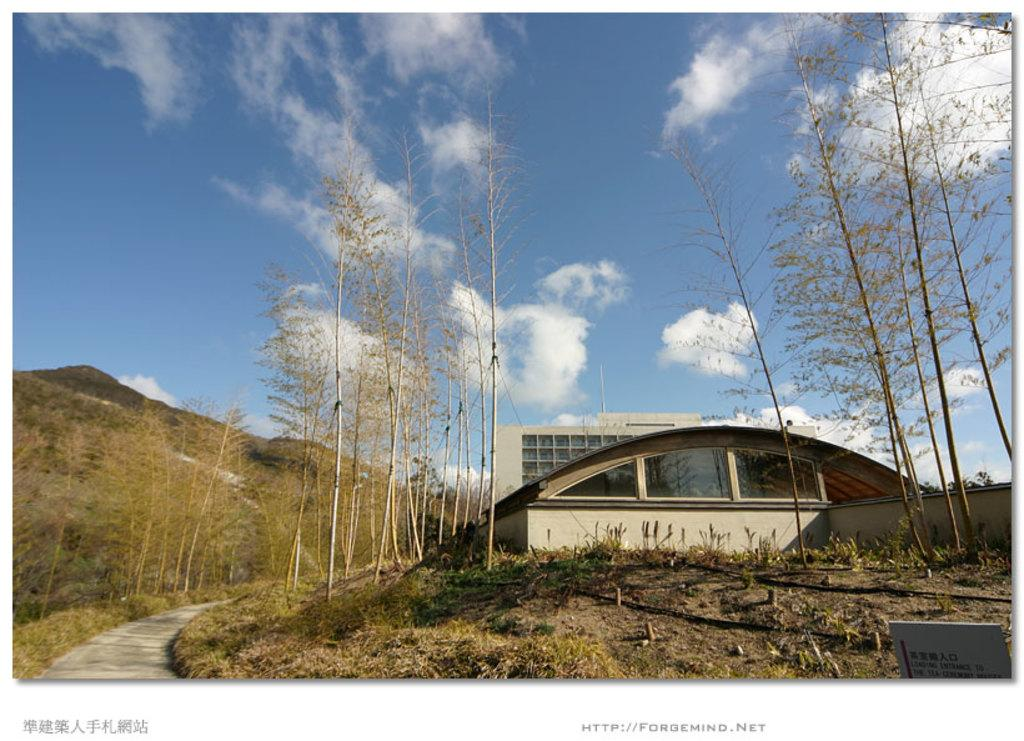What type of vegetation can be seen in the image? There are trees in the image. What is the color of the trees? The trees are green. What can be seen in the background of the image? There is a building, glass windows, and mountains in the background of the image. What is the color of the sky in the image? The sky is blue and white. How many mice are visible in the image? There are no mice present in the image. 